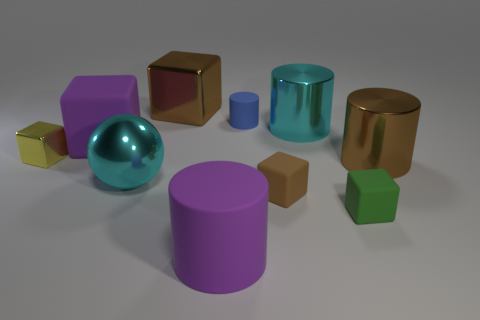There is a cyan object that is right of the small rubber cylinder; what is its material?
Give a very brief answer. Metal. Are the purple object in front of the tiny yellow metal object and the tiny blue thing made of the same material?
Offer a very short reply. Yes. What number of things are red balls or cylinders that are on the right side of the big cyan cylinder?
Your response must be concise. 1. What is the size of the purple thing that is the same shape as the yellow thing?
Your answer should be compact. Large. Is there any other thing that has the same size as the cyan sphere?
Make the answer very short. Yes. There is a brown shiny cube; are there any tiny things behind it?
Provide a short and direct response. No. There is a ball in front of the brown cylinder; is its color the same as the tiny object that is to the left of the brown metallic block?
Make the answer very short. No. Is there a big yellow matte object of the same shape as the green object?
Offer a terse response. No. How many other objects are the same color as the tiny matte cylinder?
Your response must be concise. 0. What color is the matte thing to the left of the cyan metal object on the left side of the brown metallic object that is on the left side of the large brown cylinder?
Offer a terse response. Purple. 